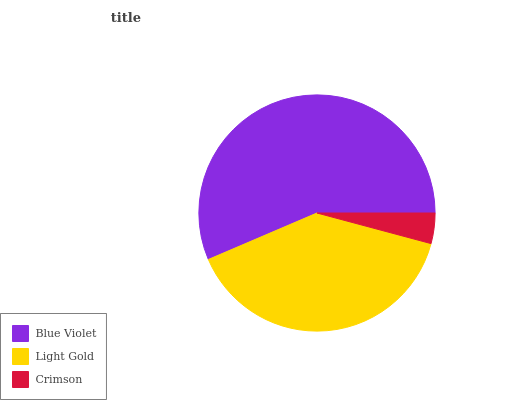Is Crimson the minimum?
Answer yes or no. Yes. Is Blue Violet the maximum?
Answer yes or no. Yes. Is Light Gold the minimum?
Answer yes or no. No. Is Light Gold the maximum?
Answer yes or no. No. Is Blue Violet greater than Light Gold?
Answer yes or no. Yes. Is Light Gold less than Blue Violet?
Answer yes or no. Yes. Is Light Gold greater than Blue Violet?
Answer yes or no. No. Is Blue Violet less than Light Gold?
Answer yes or no. No. Is Light Gold the high median?
Answer yes or no. Yes. Is Light Gold the low median?
Answer yes or no. Yes. Is Blue Violet the high median?
Answer yes or no. No. Is Blue Violet the low median?
Answer yes or no. No. 